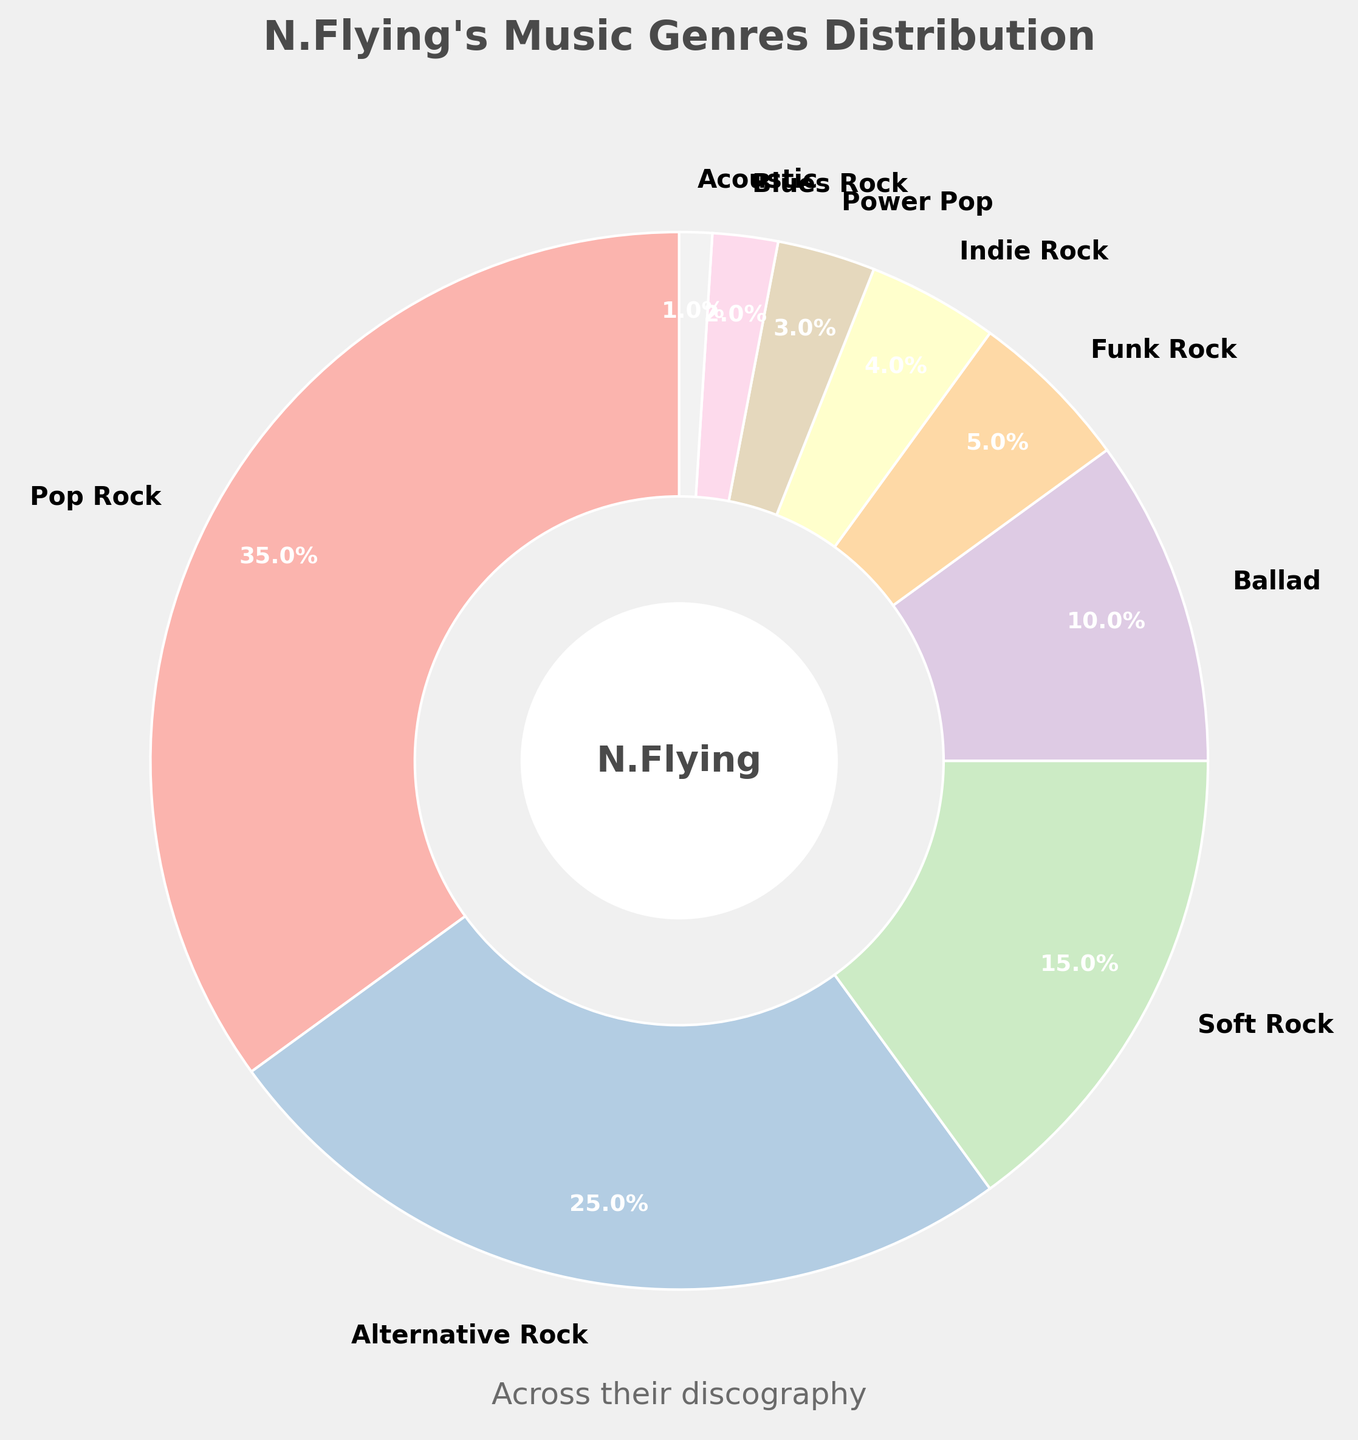What genre has the highest percentage in N.Flying's discography? The pie chart shows different genres and their respective percentages. Pop Rock has the largest slice, indicated by 35%.
Answer: Pop Rock What is the combined percentage of 'Soft Rock' and 'Ballad'? To find the combined percentage, add the percentages of both genres: 15% for Soft Rock and 10% for Ballad. Thus, 15% + 10% = 25%.
Answer: 25% Which genre makes up the smallest portion of N.Flying's music? The smallest portion on the pie chart is represented by Acoustic, which is shown as 1%.
Answer: Acoustic How much larger is 'Pop Rock' compared to 'Alternative Rock'? The percentage for Pop Rock is 35%, and for Alternative Rock, it is 25%. Calculate the difference: 35% - 25% = 10%.
Answer: 10% What's the total percentage for all Rock genres (Pop Rock, Alternative Rock, Soft Rock, Funk Rock, Indie Rock, Blues Rock)? Add the percentages of all listed Rock genres: 35% (Pop Rock) + 25% (Alternative Rock) + 15% (Soft Rock) + 5% (Funk Rock) + 4% (Indie Rock) + 2% (Blues Rock) = 86%.
Answer: 86% Which genre is between 'Ballad' and 'Indie Rock' in percentage size? Look at the percentages in descending order: Ballad (10%), followed by Funk Rock (5%), and then Indie Rock (4%). Funk Rock is between Ballad and Indie Rock.
Answer: Funk Rock What is the difference in percentage between the top two genres? The top two genres are Pop Rock (35%) and Alternative Rock (25%). The difference is 35% - 25% = 10%.
Answer: 10% How does 'Power Pop' compare to 'Blues Rock' in N.Flying's discography? Power Pop makes up 3% and Blues Rock makes up 2%. Power Pop is larger by 3% - 2% = 1%.
Answer: 1% What is the percentage difference between 'Soft Rock' and 'Ballad'? Soft Rock is 15% and Ballad is 10%. The difference is 15% - 10% = 5%.
Answer: 5% If you combine 'Funk Rock' and 'Indie Rock', does it surpass 'Soft Rock'? Funk Rock is 5% and Indie Rock is 4%, combined they are 5% + 4% = 9%, which is less than Soft Rock's 15%.
Answer: No 